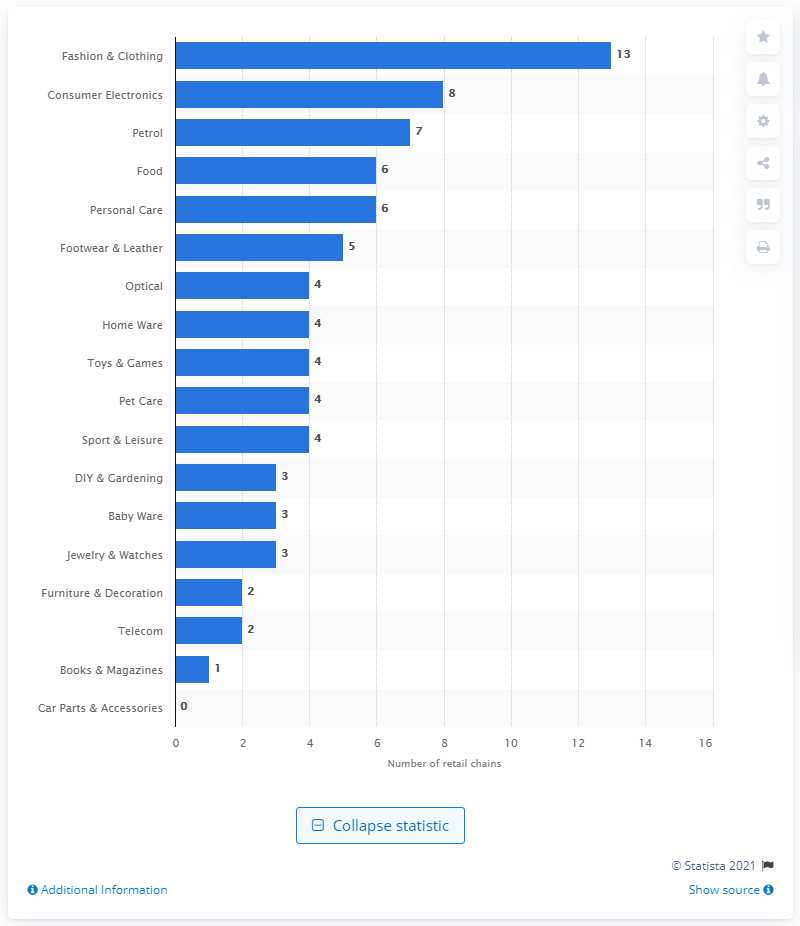Point out several critical features in this image. Luxembourg's third largest retail chain was Petrol. 